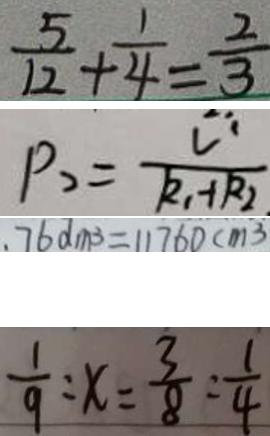Convert formula to latex. <formula><loc_0><loc_0><loc_500><loc_500>\frac { 5 } { 1 2 } + \frac { 1 } { 4 } = \frac { 2 } { 3 } 
 P _ { 2 } = \frac { U ^ { 1 } } { R _ { 1 } + R _ { 2 } } 
 . 7 6 d m ^ { 3 } = 1 1 7 6 0 c m ^ { 3 } 
 \frac { 1 } { 9 } : x = \frac { 3 } { 8 } : \frac { 1 } { 4 }</formula> 